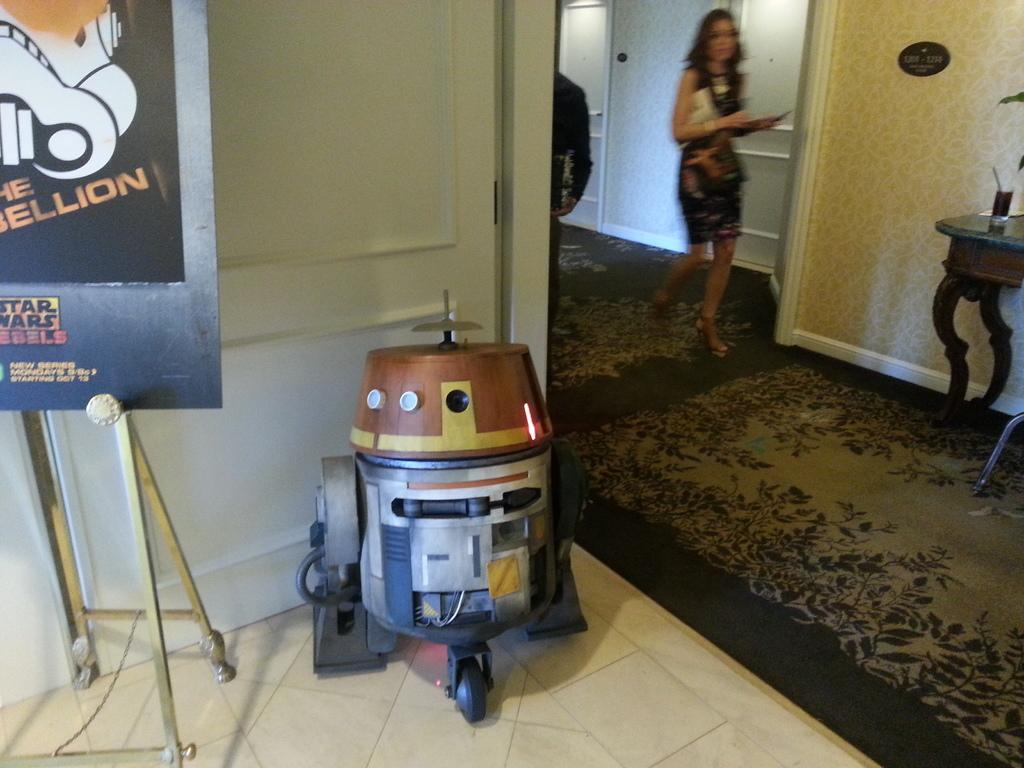Provide a one-sentence caption for the provided image. A model of a star wars character next to a Star Wars Rebels sign. 